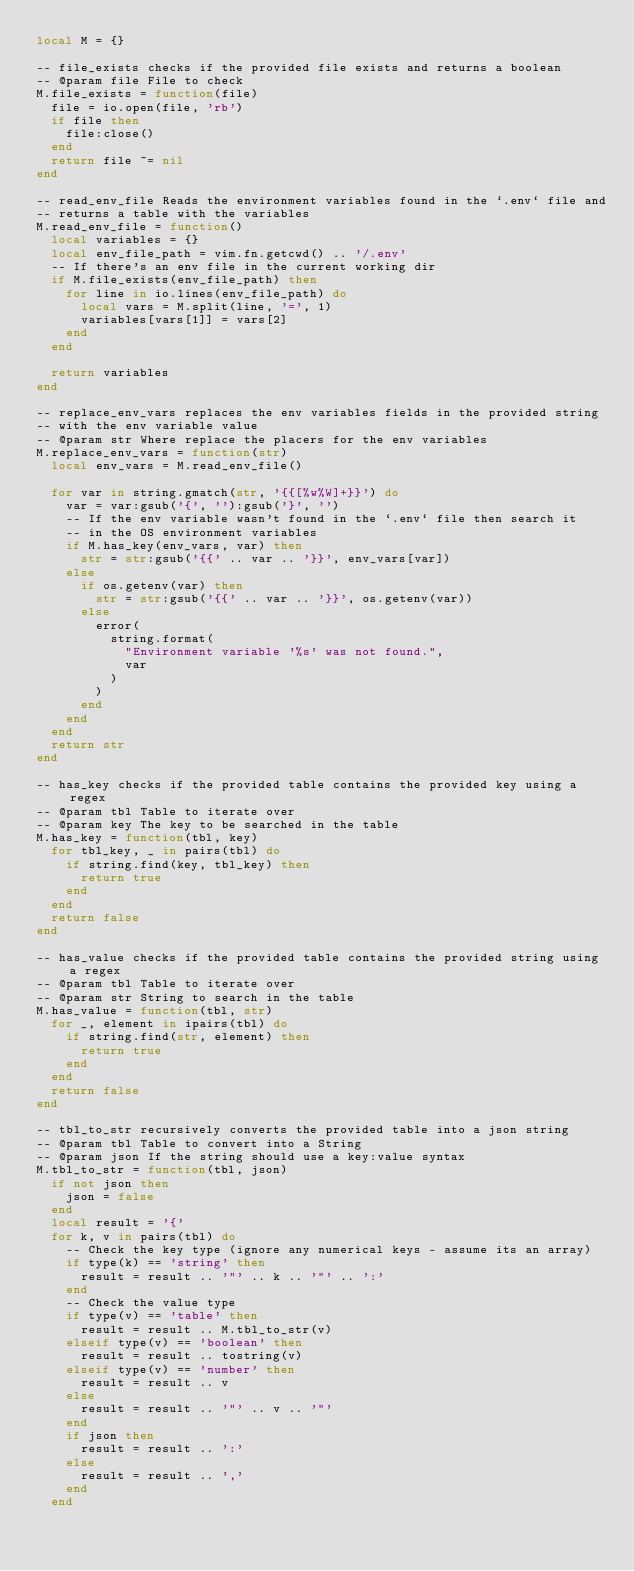Convert code to text. <code><loc_0><loc_0><loc_500><loc_500><_Lua_>local M = {}

-- file_exists checks if the provided file exists and returns a boolean
-- @param file File to check
M.file_exists = function(file)
	file = io.open(file, 'rb')
	if file then
		file:close()
	end
	return file ~= nil
end

-- read_env_file Reads the environment variables found in the `.env` file and
-- returns a table with the variables
M.read_env_file = function()
	local variables = {}
	local env_file_path = vim.fn.getcwd() .. '/.env'
	-- If there's an env file in the current working dir
	if M.file_exists(env_file_path) then
		for line in io.lines(env_file_path) do
			local vars = M.split(line, '=', 1)
			variables[vars[1]] = vars[2]
		end
	end

	return variables
end

-- replace_env_vars replaces the env variables fields in the provided string
-- with the env variable value
-- @param str Where replace the placers for the env variables
M.replace_env_vars = function(str)
	local env_vars = M.read_env_file()

	for var in string.gmatch(str, '{{[%w%W]+}}') do
		var = var:gsub('{', ''):gsub('}', '')
		-- If the env variable wasn't found in the `.env` file then search it
		-- in the OS environment variables
		if M.has_key(env_vars, var) then
			str = str:gsub('{{' .. var .. '}}', env_vars[var])
		else
			if os.getenv(var) then
				str = str:gsub('{{' .. var .. '}}', os.getenv(var))
			else
				error(
					string.format(
						"Environment variable '%s' was not found.",
						var
					)
				)
			end
		end
	end
	return str
end

-- has_key checks if the provided table contains the provided key using a regex
-- @param tbl Table to iterate over
-- @param key The key to be searched in the table
M.has_key = function(tbl, key)
	for tbl_key, _ in pairs(tbl) do
		if string.find(key, tbl_key) then
			return true
		end
	end
	return false
end

-- has_value checks if the provided table contains the provided string using a regex
-- @param tbl Table to iterate over
-- @param str String to search in the table
M.has_value = function(tbl, str)
	for _, element in ipairs(tbl) do
		if string.find(str, element) then
			return true
		end
	end
	return false
end

-- tbl_to_str recursively converts the provided table into a json string
-- @param tbl Table to convert into a String
-- @param json If the string should use a key:value syntax
M.tbl_to_str = function(tbl, json)
	if not json then
		json = false
	end
	local result = '{'
	for k, v in pairs(tbl) do
		-- Check the key type (ignore any numerical keys - assume its an array)
		if type(k) == 'string' then
			result = result .. '"' .. k .. '"' .. ':'
		end
		-- Check the value type
		if type(v) == 'table' then
			result = result .. M.tbl_to_str(v)
		elseif type(v) == 'boolean' then
			result = result .. tostring(v)
		elseif type(v) == 'number' then
			result = result .. v
		else
			result = result .. '"' .. v .. '"'
		end
		if json then
			result = result .. ':'
		else
			result = result .. ','
		end
	end</code> 